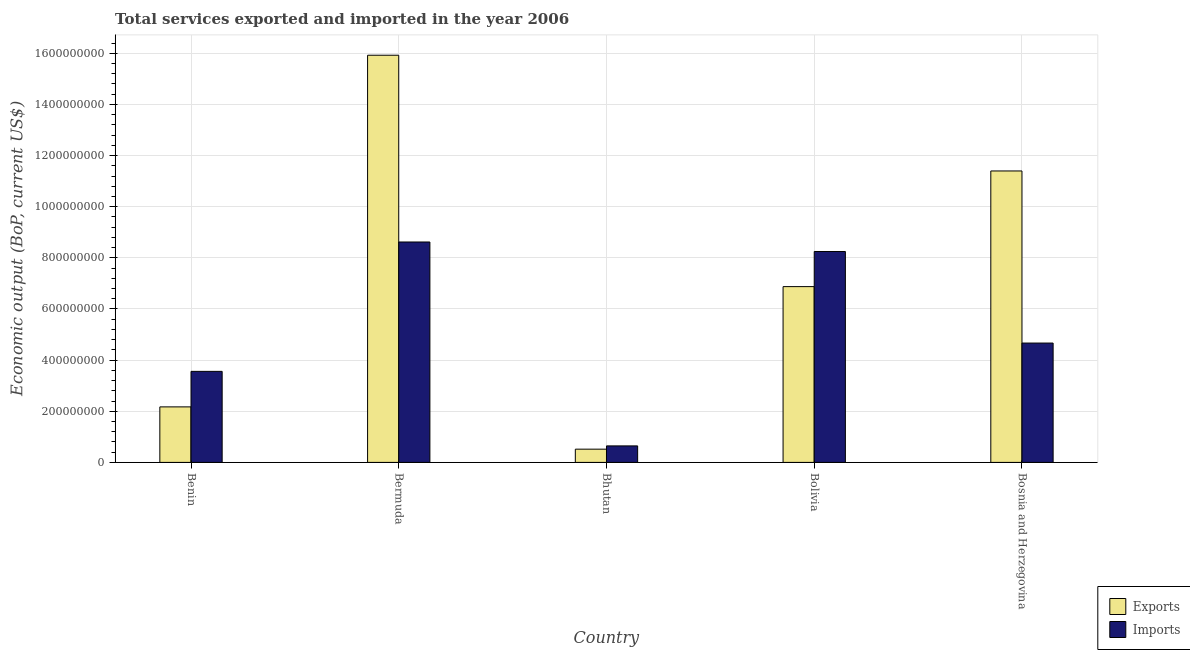How many different coloured bars are there?
Your answer should be very brief. 2. How many groups of bars are there?
Make the answer very short. 5. Are the number of bars per tick equal to the number of legend labels?
Make the answer very short. Yes. How many bars are there on the 2nd tick from the left?
Ensure brevity in your answer.  2. What is the label of the 2nd group of bars from the left?
Provide a short and direct response. Bermuda. What is the amount of service imports in Bolivia?
Make the answer very short. 8.25e+08. Across all countries, what is the maximum amount of service exports?
Provide a succinct answer. 1.59e+09. Across all countries, what is the minimum amount of service imports?
Your answer should be very brief. 6.45e+07. In which country was the amount of service exports maximum?
Offer a terse response. Bermuda. In which country was the amount of service exports minimum?
Provide a short and direct response. Bhutan. What is the total amount of service imports in the graph?
Your answer should be compact. 2.57e+09. What is the difference between the amount of service imports in Benin and that in Bhutan?
Offer a terse response. 2.91e+08. What is the difference between the amount of service imports in Bermuda and the amount of service exports in Bolivia?
Ensure brevity in your answer.  1.75e+08. What is the average amount of service exports per country?
Your answer should be very brief. 7.38e+08. What is the difference between the amount of service exports and amount of service imports in Bhutan?
Give a very brief answer. -1.28e+07. In how many countries, is the amount of service imports greater than 840000000 US$?
Give a very brief answer. 1. What is the ratio of the amount of service exports in Benin to that in Bhutan?
Provide a short and direct response. 4.2. What is the difference between the highest and the second highest amount of service imports?
Give a very brief answer. 3.71e+07. What is the difference between the highest and the lowest amount of service imports?
Make the answer very short. 7.97e+08. In how many countries, is the amount of service imports greater than the average amount of service imports taken over all countries?
Provide a short and direct response. 2. Is the sum of the amount of service exports in Bermuda and Bhutan greater than the maximum amount of service imports across all countries?
Your response must be concise. Yes. What does the 2nd bar from the left in Benin represents?
Your answer should be very brief. Imports. What does the 1st bar from the right in Bolivia represents?
Give a very brief answer. Imports. What is the difference between two consecutive major ticks on the Y-axis?
Offer a very short reply. 2.00e+08. Does the graph contain any zero values?
Offer a very short reply. No. Where does the legend appear in the graph?
Provide a short and direct response. Bottom right. How many legend labels are there?
Your answer should be very brief. 2. What is the title of the graph?
Ensure brevity in your answer.  Total services exported and imported in the year 2006. What is the label or title of the Y-axis?
Your response must be concise. Economic output (BoP, current US$). What is the Economic output (BoP, current US$) of Exports in Benin?
Give a very brief answer. 2.17e+08. What is the Economic output (BoP, current US$) of Imports in Benin?
Offer a very short reply. 3.56e+08. What is the Economic output (BoP, current US$) in Exports in Bermuda?
Provide a short and direct response. 1.59e+09. What is the Economic output (BoP, current US$) in Imports in Bermuda?
Give a very brief answer. 8.62e+08. What is the Economic output (BoP, current US$) of Exports in Bhutan?
Keep it short and to the point. 5.17e+07. What is the Economic output (BoP, current US$) in Imports in Bhutan?
Provide a short and direct response. 6.45e+07. What is the Economic output (BoP, current US$) of Exports in Bolivia?
Your response must be concise. 6.87e+08. What is the Economic output (BoP, current US$) of Imports in Bolivia?
Offer a very short reply. 8.25e+08. What is the Economic output (BoP, current US$) of Exports in Bosnia and Herzegovina?
Your answer should be very brief. 1.14e+09. What is the Economic output (BoP, current US$) in Imports in Bosnia and Herzegovina?
Your answer should be compact. 4.67e+08. Across all countries, what is the maximum Economic output (BoP, current US$) in Exports?
Provide a succinct answer. 1.59e+09. Across all countries, what is the maximum Economic output (BoP, current US$) of Imports?
Offer a very short reply. 8.62e+08. Across all countries, what is the minimum Economic output (BoP, current US$) of Exports?
Your answer should be very brief. 5.17e+07. Across all countries, what is the minimum Economic output (BoP, current US$) in Imports?
Your answer should be very brief. 6.45e+07. What is the total Economic output (BoP, current US$) in Exports in the graph?
Provide a short and direct response. 3.69e+09. What is the total Economic output (BoP, current US$) of Imports in the graph?
Ensure brevity in your answer.  2.57e+09. What is the difference between the Economic output (BoP, current US$) of Exports in Benin and that in Bermuda?
Give a very brief answer. -1.38e+09. What is the difference between the Economic output (BoP, current US$) in Imports in Benin and that in Bermuda?
Your answer should be very brief. -5.06e+08. What is the difference between the Economic output (BoP, current US$) of Exports in Benin and that in Bhutan?
Your answer should be compact. 1.65e+08. What is the difference between the Economic output (BoP, current US$) in Imports in Benin and that in Bhutan?
Your response must be concise. 2.91e+08. What is the difference between the Economic output (BoP, current US$) in Exports in Benin and that in Bolivia?
Offer a terse response. -4.70e+08. What is the difference between the Economic output (BoP, current US$) in Imports in Benin and that in Bolivia?
Your answer should be compact. -4.69e+08. What is the difference between the Economic output (BoP, current US$) in Exports in Benin and that in Bosnia and Herzegovina?
Ensure brevity in your answer.  -9.23e+08. What is the difference between the Economic output (BoP, current US$) in Imports in Benin and that in Bosnia and Herzegovina?
Provide a short and direct response. -1.11e+08. What is the difference between the Economic output (BoP, current US$) in Exports in Bermuda and that in Bhutan?
Your answer should be very brief. 1.54e+09. What is the difference between the Economic output (BoP, current US$) of Imports in Bermuda and that in Bhutan?
Offer a very short reply. 7.97e+08. What is the difference between the Economic output (BoP, current US$) of Exports in Bermuda and that in Bolivia?
Provide a short and direct response. 9.05e+08. What is the difference between the Economic output (BoP, current US$) in Imports in Bermuda and that in Bolivia?
Give a very brief answer. 3.71e+07. What is the difference between the Economic output (BoP, current US$) in Exports in Bermuda and that in Bosnia and Herzegovina?
Your response must be concise. 4.53e+08. What is the difference between the Economic output (BoP, current US$) of Imports in Bermuda and that in Bosnia and Herzegovina?
Offer a very short reply. 3.95e+08. What is the difference between the Economic output (BoP, current US$) of Exports in Bhutan and that in Bolivia?
Your answer should be compact. -6.36e+08. What is the difference between the Economic output (BoP, current US$) of Imports in Bhutan and that in Bolivia?
Offer a terse response. -7.60e+08. What is the difference between the Economic output (BoP, current US$) of Exports in Bhutan and that in Bosnia and Herzegovina?
Make the answer very short. -1.09e+09. What is the difference between the Economic output (BoP, current US$) in Imports in Bhutan and that in Bosnia and Herzegovina?
Provide a succinct answer. -4.02e+08. What is the difference between the Economic output (BoP, current US$) of Exports in Bolivia and that in Bosnia and Herzegovina?
Provide a short and direct response. -4.52e+08. What is the difference between the Economic output (BoP, current US$) in Imports in Bolivia and that in Bosnia and Herzegovina?
Offer a very short reply. 3.58e+08. What is the difference between the Economic output (BoP, current US$) of Exports in Benin and the Economic output (BoP, current US$) of Imports in Bermuda?
Ensure brevity in your answer.  -6.45e+08. What is the difference between the Economic output (BoP, current US$) of Exports in Benin and the Economic output (BoP, current US$) of Imports in Bhutan?
Your answer should be very brief. 1.53e+08. What is the difference between the Economic output (BoP, current US$) in Exports in Benin and the Economic output (BoP, current US$) in Imports in Bolivia?
Give a very brief answer. -6.08e+08. What is the difference between the Economic output (BoP, current US$) of Exports in Benin and the Economic output (BoP, current US$) of Imports in Bosnia and Herzegovina?
Your answer should be compact. -2.50e+08. What is the difference between the Economic output (BoP, current US$) in Exports in Bermuda and the Economic output (BoP, current US$) in Imports in Bhutan?
Give a very brief answer. 1.53e+09. What is the difference between the Economic output (BoP, current US$) of Exports in Bermuda and the Economic output (BoP, current US$) of Imports in Bolivia?
Give a very brief answer. 7.68e+08. What is the difference between the Economic output (BoP, current US$) of Exports in Bermuda and the Economic output (BoP, current US$) of Imports in Bosnia and Herzegovina?
Provide a succinct answer. 1.13e+09. What is the difference between the Economic output (BoP, current US$) in Exports in Bhutan and the Economic output (BoP, current US$) in Imports in Bolivia?
Provide a short and direct response. -7.73e+08. What is the difference between the Economic output (BoP, current US$) in Exports in Bhutan and the Economic output (BoP, current US$) in Imports in Bosnia and Herzegovina?
Your answer should be compact. -4.15e+08. What is the difference between the Economic output (BoP, current US$) of Exports in Bolivia and the Economic output (BoP, current US$) of Imports in Bosnia and Herzegovina?
Give a very brief answer. 2.21e+08. What is the average Economic output (BoP, current US$) of Exports per country?
Offer a terse response. 7.38e+08. What is the average Economic output (BoP, current US$) in Imports per country?
Provide a short and direct response. 5.15e+08. What is the difference between the Economic output (BoP, current US$) in Exports and Economic output (BoP, current US$) in Imports in Benin?
Provide a short and direct response. -1.39e+08. What is the difference between the Economic output (BoP, current US$) of Exports and Economic output (BoP, current US$) of Imports in Bermuda?
Provide a succinct answer. 7.30e+08. What is the difference between the Economic output (BoP, current US$) of Exports and Economic output (BoP, current US$) of Imports in Bhutan?
Offer a terse response. -1.28e+07. What is the difference between the Economic output (BoP, current US$) of Exports and Economic output (BoP, current US$) of Imports in Bolivia?
Make the answer very short. -1.37e+08. What is the difference between the Economic output (BoP, current US$) of Exports and Economic output (BoP, current US$) of Imports in Bosnia and Herzegovina?
Ensure brevity in your answer.  6.73e+08. What is the ratio of the Economic output (BoP, current US$) in Exports in Benin to that in Bermuda?
Keep it short and to the point. 0.14. What is the ratio of the Economic output (BoP, current US$) of Imports in Benin to that in Bermuda?
Offer a very short reply. 0.41. What is the ratio of the Economic output (BoP, current US$) in Exports in Benin to that in Bhutan?
Offer a terse response. 4.2. What is the ratio of the Economic output (BoP, current US$) in Imports in Benin to that in Bhutan?
Ensure brevity in your answer.  5.52. What is the ratio of the Economic output (BoP, current US$) in Exports in Benin to that in Bolivia?
Offer a terse response. 0.32. What is the ratio of the Economic output (BoP, current US$) in Imports in Benin to that in Bolivia?
Keep it short and to the point. 0.43. What is the ratio of the Economic output (BoP, current US$) of Exports in Benin to that in Bosnia and Herzegovina?
Keep it short and to the point. 0.19. What is the ratio of the Economic output (BoP, current US$) in Imports in Benin to that in Bosnia and Herzegovina?
Give a very brief answer. 0.76. What is the ratio of the Economic output (BoP, current US$) in Exports in Bermuda to that in Bhutan?
Your response must be concise. 30.79. What is the ratio of the Economic output (BoP, current US$) in Imports in Bermuda to that in Bhutan?
Offer a terse response. 13.36. What is the ratio of the Economic output (BoP, current US$) in Exports in Bermuda to that in Bolivia?
Ensure brevity in your answer.  2.32. What is the ratio of the Economic output (BoP, current US$) of Imports in Bermuda to that in Bolivia?
Provide a short and direct response. 1.04. What is the ratio of the Economic output (BoP, current US$) in Exports in Bermuda to that in Bosnia and Herzegovina?
Your response must be concise. 1.4. What is the ratio of the Economic output (BoP, current US$) in Imports in Bermuda to that in Bosnia and Herzegovina?
Provide a short and direct response. 1.85. What is the ratio of the Economic output (BoP, current US$) of Exports in Bhutan to that in Bolivia?
Make the answer very short. 0.08. What is the ratio of the Economic output (BoP, current US$) in Imports in Bhutan to that in Bolivia?
Make the answer very short. 0.08. What is the ratio of the Economic output (BoP, current US$) of Exports in Bhutan to that in Bosnia and Herzegovina?
Your answer should be very brief. 0.05. What is the ratio of the Economic output (BoP, current US$) of Imports in Bhutan to that in Bosnia and Herzegovina?
Your response must be concise. 0.14. What is the ratio of the Economic output (BoP, current US$) in Exports in Bolivia to that in Bosnia and Herzegovina?
Ensure brevity in your answer.  0.6. What is the ratio of the Economic output (BoP, current US$) in Imports in Bolivia to that in Bosnia and Herzegovina?
Your answer should be very brief. 1.77. What is the difference between the highest and the second highest Economic output (BoP, current US$) in Exports?
Your answer should be compact. 4.53e+08. What is the difference between the highest and the second highest Economic output (BoP, current US$) in Imports?
Your answer should be very brief. 3.71e+07. What is the difference between the highest and the lowest Economic output (BoP, current US$) in Exports?
Keep it short and to the point. 1.54e+09. What is the difference between the highest and the lowest Economic output (BoP, current US$) of Imports?
Offer a terse response. 7.97e+08. 